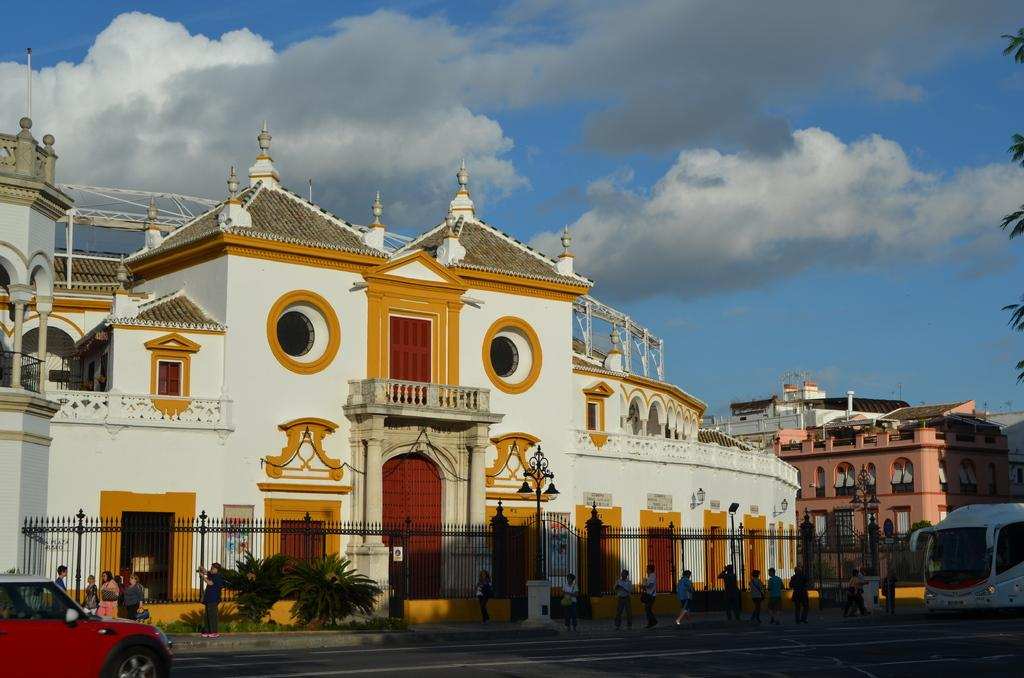What can be seen in the sky in the image? The sky with clouds is visible in the image. What type of structures are present in the image? There are buildings in the image. What are the vertical structures on the sides of the road in the image? Street poles are present in the image. What are the sources of light visible on the street poles? Street lights are visible in the image. What type of barrier is present in the image? There is an iron grill in the image. What type of vegetation is present in the image? Trees and plants are visible in the image. What type of transportation is present in the image? Motor vehicles are in the image. What are the wires connecting the buildings and poles in the image? Electric cables are present in the image. What are the people doing on the road in the image? Persons are on the road in the image. What type of bit can be seen in the field in the image? There is no field or bit present in the image. How does the person push the invisible object in the image? There is no invisible object or pushing action depicted in the image. 